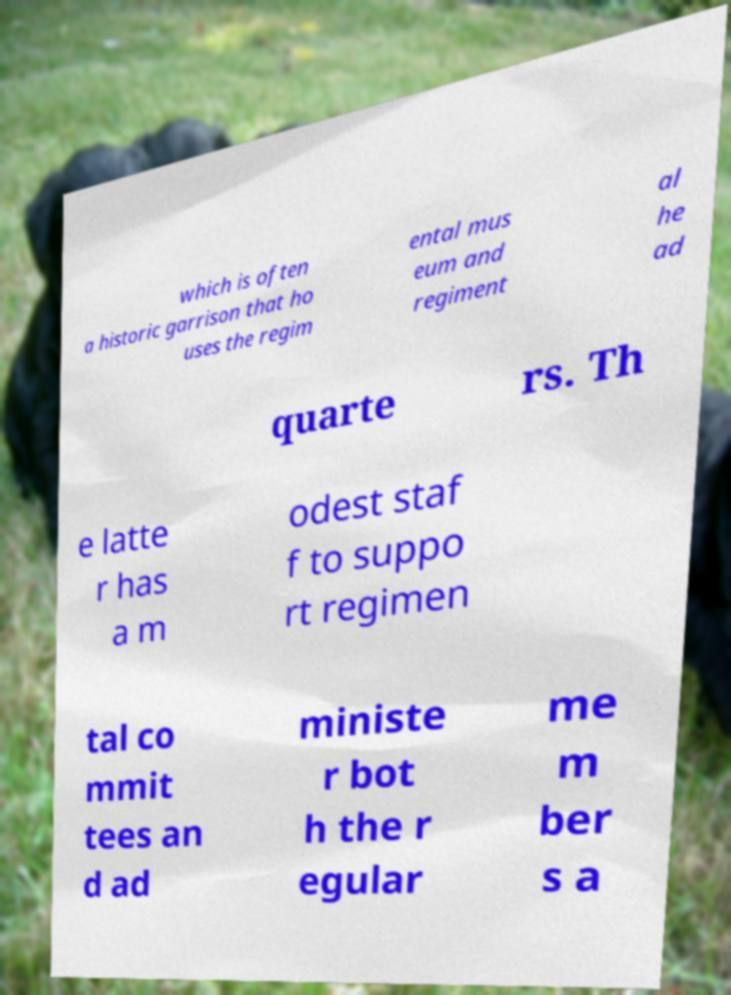Can you accurately transcribe the text from the provided image for me? which is often a historic garrison that ho uses the regim ental mus eum and regiment al he ad quarte rs. Th e latte r has a m odest staf f to suppo rt regimen tal co mmit tees an d ad ministe r bot h the r egular me m ber s a 